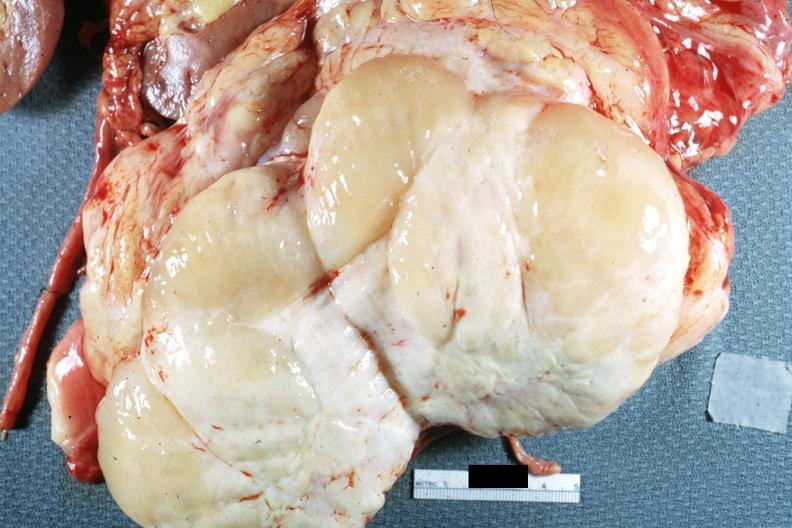how is nodular tumor cut surface natural color yellow and white gross sarcoma?
Answer the question using a single word or phrase. Typical 